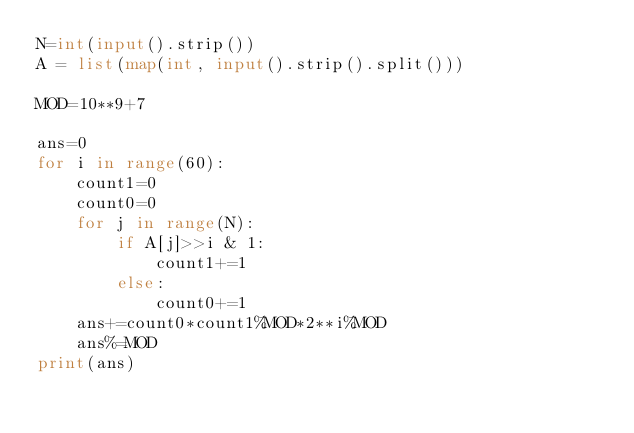Convert code to text. <code><loc_0><loc_0><loc_500><loc_500><_Python_>N=int(input().strip())
A = list(map(int, input().strip().split()))

MOD=10**9+7

ans=0
for i in range(60):
    count1=0
    count0=0
    for j in range(N):
        if A[j]>>i & 1:
            count1+=1
        else:
            count0+=1
    ans+=count0*count1%MOD*2**i%MOD
    ans%=MOD
print(ans)</code> 